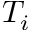Convert formula to latex. <formula><loc_0><loc_0><loc_500><loc_500>T _ { i }</formula> 